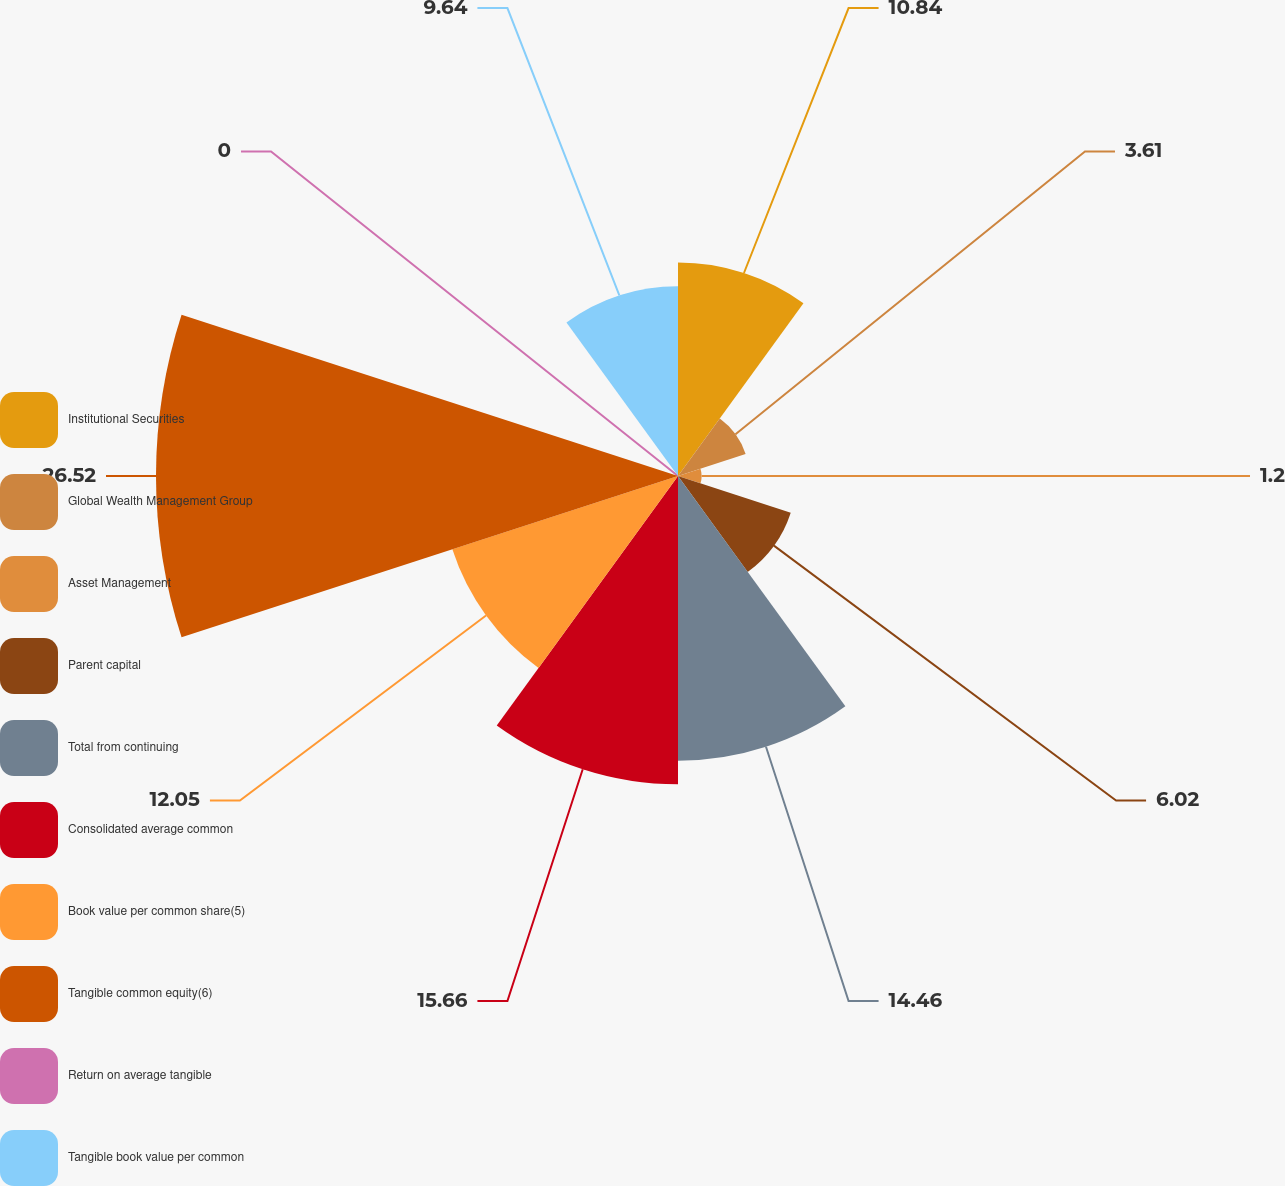<chart> <loc_0><loc_0><loc_500><loc_500><pie_chart><fcel>Institutional Securities<fcel>Global Wealth Management Group<fcel>Asset Management<fcel>Parent capital<fcel>Total from continuing<fcel>Consolidated average common<fcel>Book value per common share(5)<fcel>Tangible common equity(6)<fcel>Return on average tangible<fcel>Tangible book value per common<nl><fcel>10.84%<fcel>3.61%<fcel>1.2%<fcel>6.02%<fcel>14.46%<fcel>15.66%<fcel>12.05%<fcel>26.51%<fcel>0.0%<fcel>9.64%<nl></chart> 